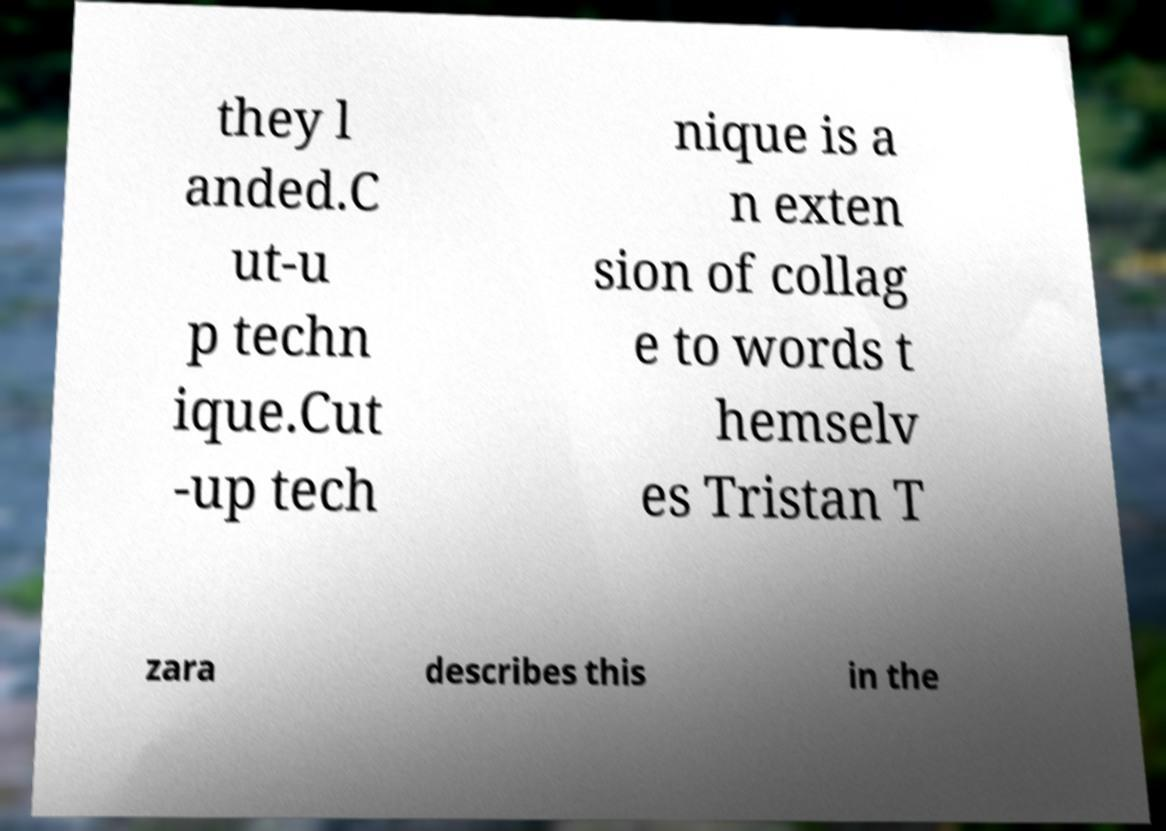Could you assist in decoding the text presented in this image and type it out clearly? they l anded.C ut-u p techn ique.Cut -up tech nique is a n exten sion of collag e to words t hemselv es Tristan T zara describes this in the 